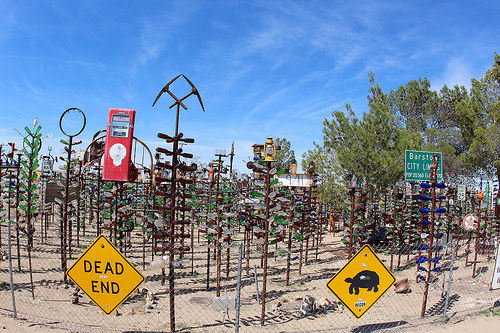<image>
Can you confirm if the cage is behind the sign? No. The cage is not behind the sign. From this viewpoint, the cage appears to be positioned elsewhere in the scene. Where is the tree in relation to the sign? Is it to the right of the sign? Yes. From this viewpoint, the tree is positioned to the right side relative to the sign. Is the tree next to the sky? Yes. The tree is positioned adjacent to the sky, located nearby in the same general area. 